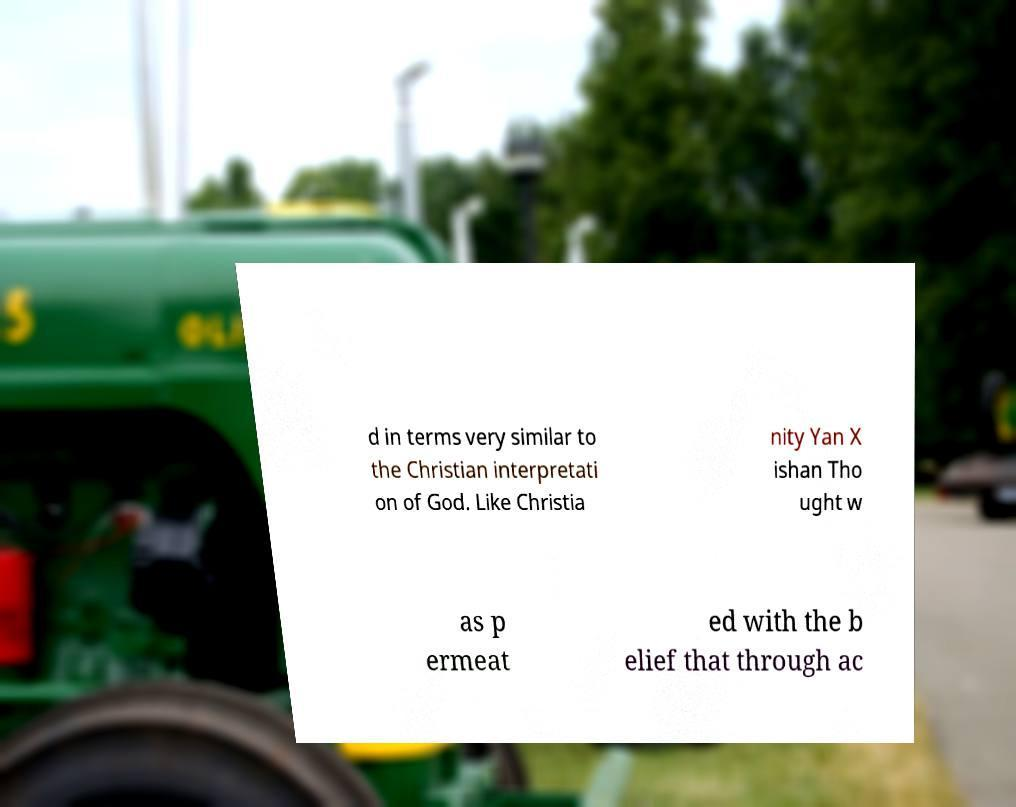There's text embedded in this image that I need extracted. Can you transcribe it verbatim? d in terms very similar to the Christian interpretati on of God. Like Christia nity Yan X ishan Tho ught w as p ermeat ed with the b elief that through ac 